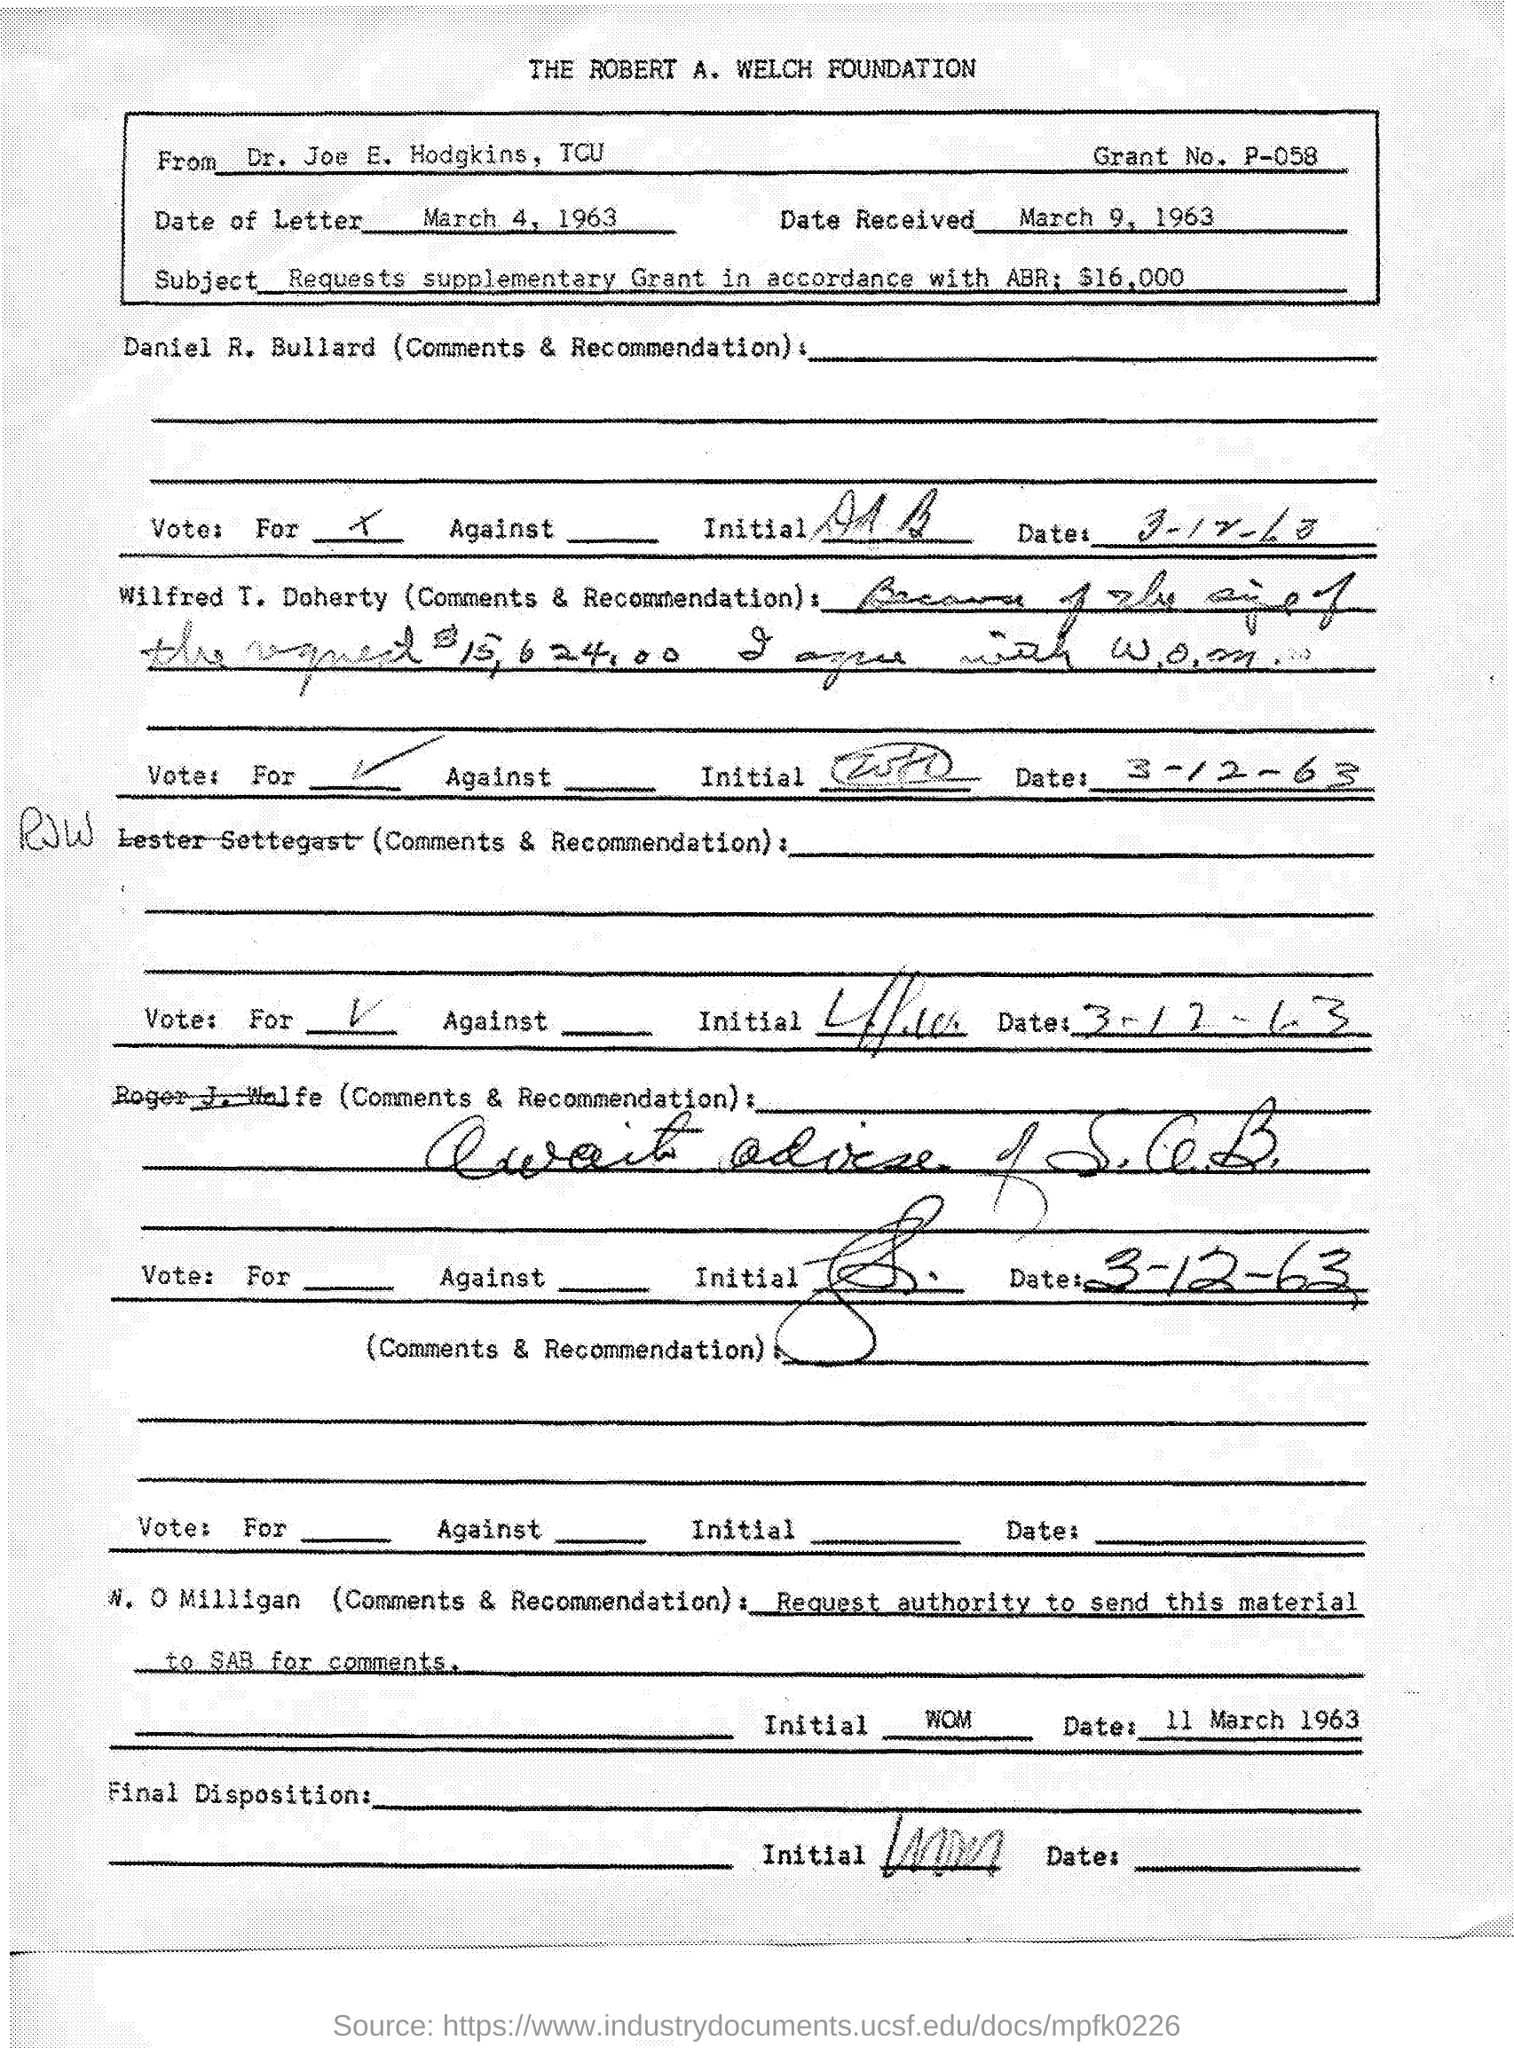Which foundation is mentioned at the top of the page?
Your answer should be very brief. THE ROBERT A. WELCH FOUNDATION. From whom is the document?
Provide a succinct answer. Dr. Joe E. Hodgkins, TCU. What is the grant No.?
Your answer should be compact. P-058. When is the letter dated?
Your answer should be compact. March 4, 1963. When was the letter received?
Give a very brief answer. March 9, 1963. What is the subject of the letter?
Give a very brief answer. Requests supplementary Grant in accordance with ABR: $16,000. 